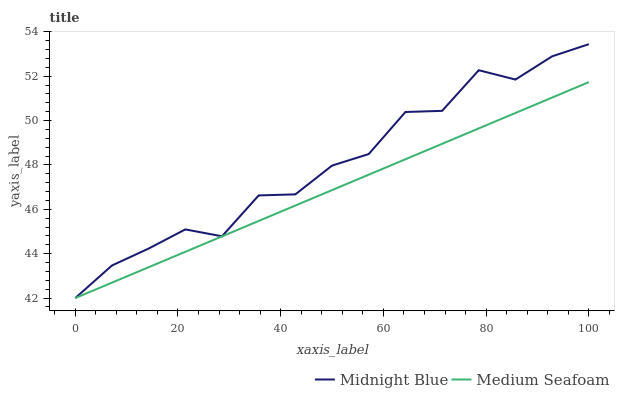Does Medium Seafoam have the maximum area under the curve?
Answer yes or no. No. Is Medium Seafoam the roughest?
Answer yes or no. No. Does Medium Seafoam have the highest value?
Answer yes or no. No. 